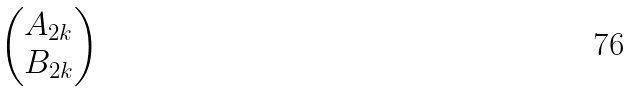<formula> <loc_0><loc_0><loc_500><loc_500>\begin{pmatrix} A _ { 2 k } \\ B _ { 2 k } \end{pmatrix}</formula> 